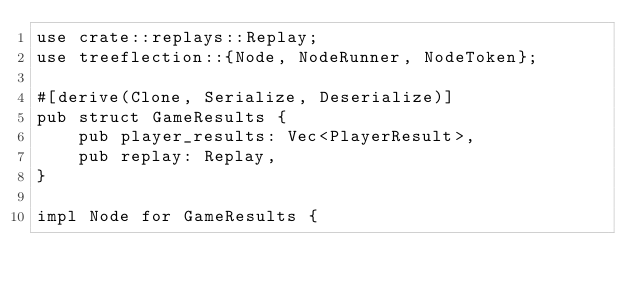<code> <loc_0><loc_0><loc_500><loc_500><_Rust_>use crate::replays::Replay;
use treeflection::{Node, NodeRunner, NodeToken};

#[derive(Clone, Serialize, Deserialize)]
pub struct GameResults {
    pub player_results: Vec<PlayerResult>,
    pub replay: Replay,
}

impl Node for GameResults {</code> 